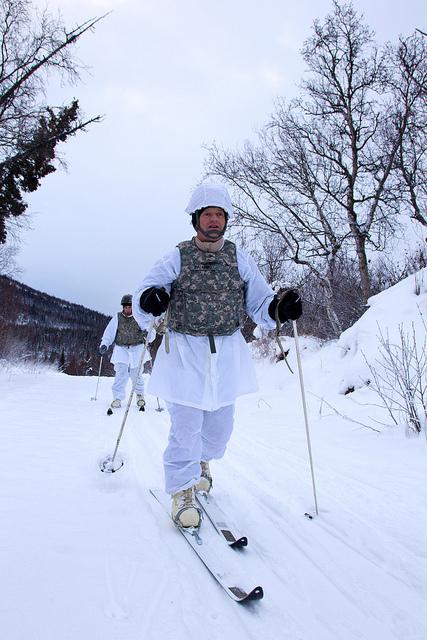Where are the people snow skiing?
Be succinct. Mountain. How many people are skiing?
Keep it brief. 2. Is the man going up a hill?
Concise answer only. No. Is it snowing here?
Concise answer only. No. 